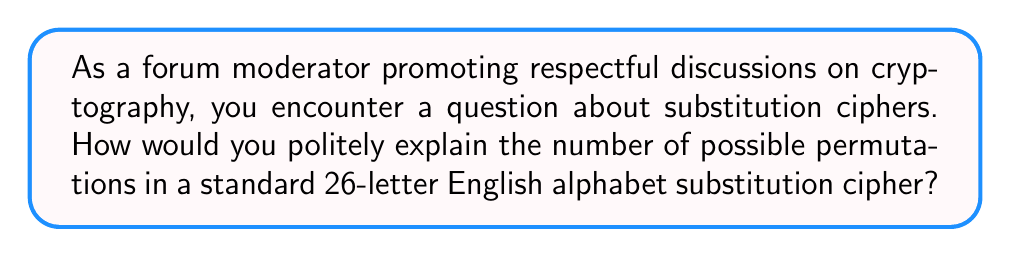Could you help me with this problem? To explain this courteously to forum members, we can break it down step-by-step:

1) In a substitution cipher, each letter of the alphabet is replaced by another letter.

2) For the first letter, we have 26 choices, as any letter can be substituted for it.

3) For the second letter, we have 25 choices, as one letter has already been used.

4) This pattern continues, with each subsequent letter having one fewer choice.

5) Mathematically, this is represented by the factorial of 26, written as 26!

6) The factorial is calculated as:

   $$26! = 26 \times 25 \times 24 \times ... \times 3 \times 2 \times 1$$

7) This can be computed:

   $$26! = 403,291,461,126,605,635,584,000,000$$

8) To put this in perspective, we could politely mention that this is an enormously large number, far exceeding the number of stars in the observable universe.
Answer: $26! = 403,291,461,126,605,635,584,000,000$ 